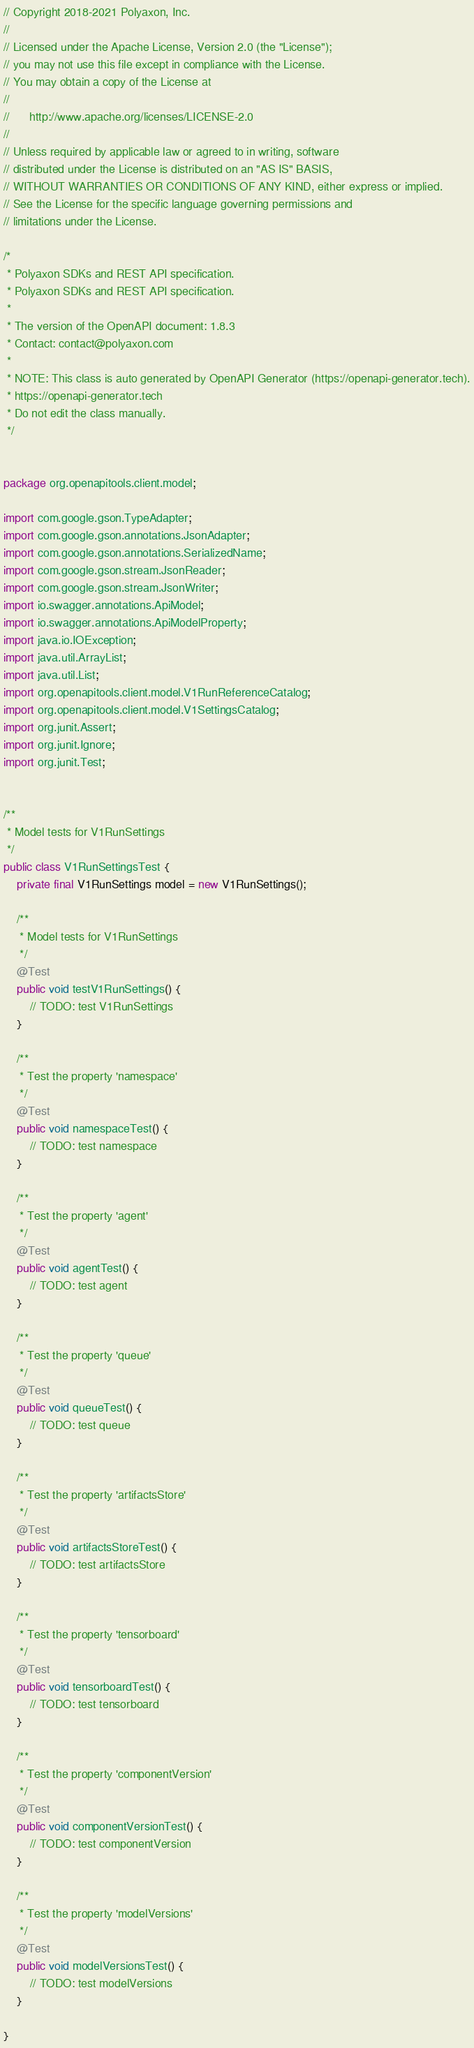Convert code to text. <code><loc_0><loc_0><loc_500><loc_500><_Java_>// Copyright 2018-2021 Polyaxon, Inc.
//
// Licensed under the Apache License, Version 2.0 (the "License");
// you may not use this file except in compliance with the License.
// You may obtain a copy of the License at
//
//      http://www.apache.org/licenses/LICENSE-2.0
//
// Unless required by applicable law or agreed to in writing, software
// distributed under the License is distributed on an "AS IS" BASIS,
// WITHOUT WARRANTIES OR CONDITIONS OF ANY KIND, either express or implied.
// See the License for the specific language governing permissions and
// limitations under the License.

/*
 * Polyaxon SDKs and REST API specification.
 * Polyaxon SDKs and REST API specification.
 *
 * The version of the OpenAPI document: 1.8.3
 * Contact: contact@polyaxon.com
 *
 * NOTE: This class is auto generated by OpenAPI Generator (https://openapi-generator.tech).
 * https://openapi-generator.tech
 * Do not edit the class manually.
 */


package org.openapitools.client.model;

import com.google.gson.TypeAdapter;
import com.google.gson.annotations.JsonAdapter;
import com.google.gson.annotations.SerializedName;
import com.google.gson.stream.JsonReader;
import com.google.gson.stream.JsonWriter;
import io.swagger.annotations.ApiModel;
import io.swagger.annotations.ApiModelProperty;
import java.io.IOException;
import java.util.ArrayList;
import java.util.List;
import org.openapitools.client.model.V1RunReferenceCatalog;
import org.openapitools.client.model.V1SettingsCatalog;
import org.junit.Assert;
import org.junit.Ignore;
import org.junit.Test;


/**
 * Model tests for V1RunSettings
 */
public class V1RunSettingsTest {
    private final V1RunSettings model = new V1RunSettings();

    /**
     * Model tests for V1RunSettings
     */
    @Test
    public void testV1RunSettings() {
        // TODO: test V1RunSettings
    }

    /**
     * Test the property 'namespace'
     */
    @Test
    public void namespaceTest() {
        // TODO: test namespace
    }

    /**
     * Test the property 'agent'
     */
    @Test
    public void agentTest() {
        // TODO: test agent
    }

    /**
     * Test the property 'queue'
     */
    @Test
    public void queueTest() {
        // TODO: test queue
    }

    /**
     * Test the property 'artifactsStore'
     */
    @Test
    public void artifactsStoreTest() {
        // TODO: test artifactsStore
    }

    /**
     * Test the property 'tensorboard'
     */
    @Test
    public void tensorboardTest() {
        // TODO: test tensorboard
    }

    /**
     * Test the property 'componentVersion'
     */
    @Test
    public void componentVersionTest() {
        // TODO: test componentVersion
    }

    /**
     * Test the property 'modelVersions'
     */
    @Test
    public void modelVersionsTest() {
        // TODO: test modelVersions
    }

}
</code> 